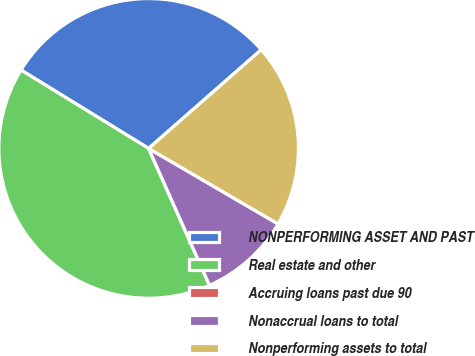<chart> <loc_0><loc_0><loc_500><loc_500><pie_chart><fcel>NONPERFORMING ASSET AND PAST<fcel>Real estate and other<fcel>Accruing loans past due 90<fcel>Nonaccrual loans to total<fcel>Nonperforming assets to total<nl><fcel>29.78%<fcel>40.43%<fcel>0.0%<fcel>9.93%<fcel>19.86%<nl></chart> 